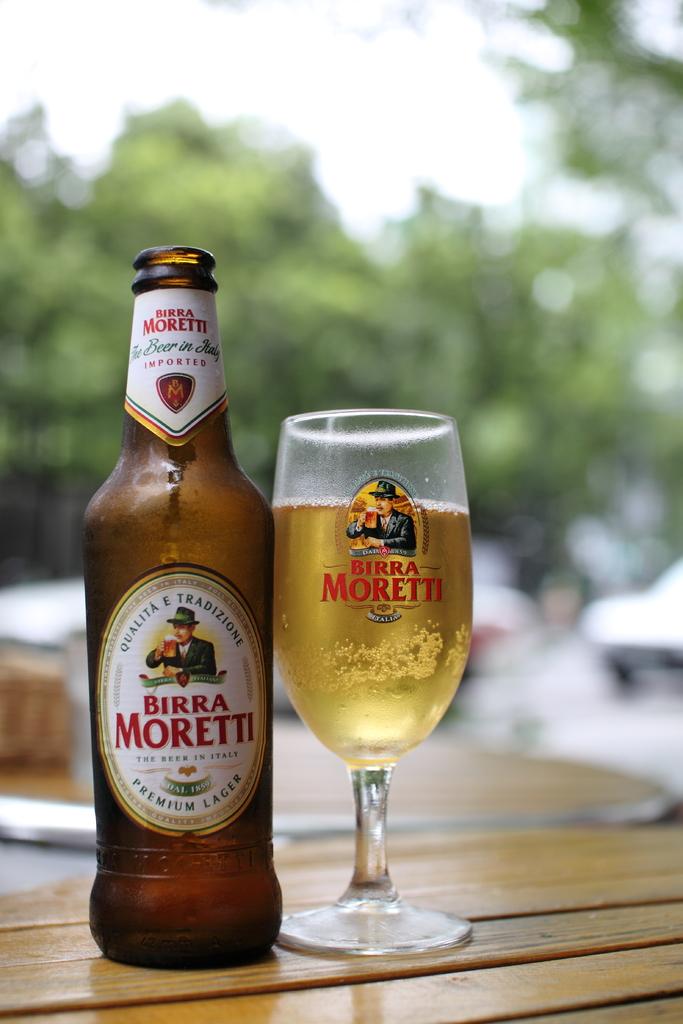What is the brand name of the drink?
Keep it short and to the point. Birra moretti. 